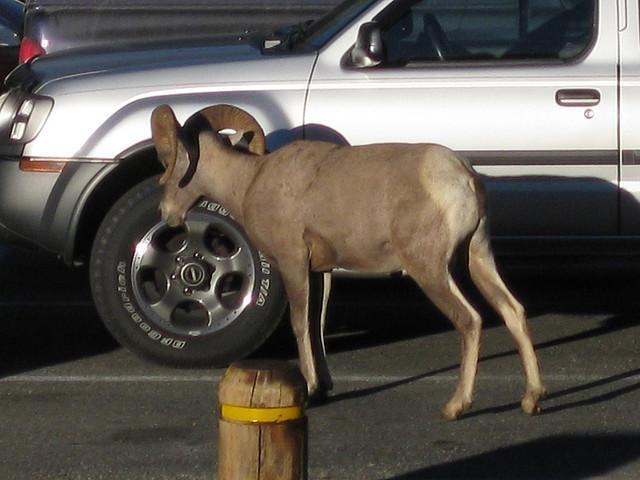How many people are in the car?
Give a very brief answer. 0. How many cars are there?
Give a very brief answer. 2. How many sheep are there?
Give a very brief answer. 1. 